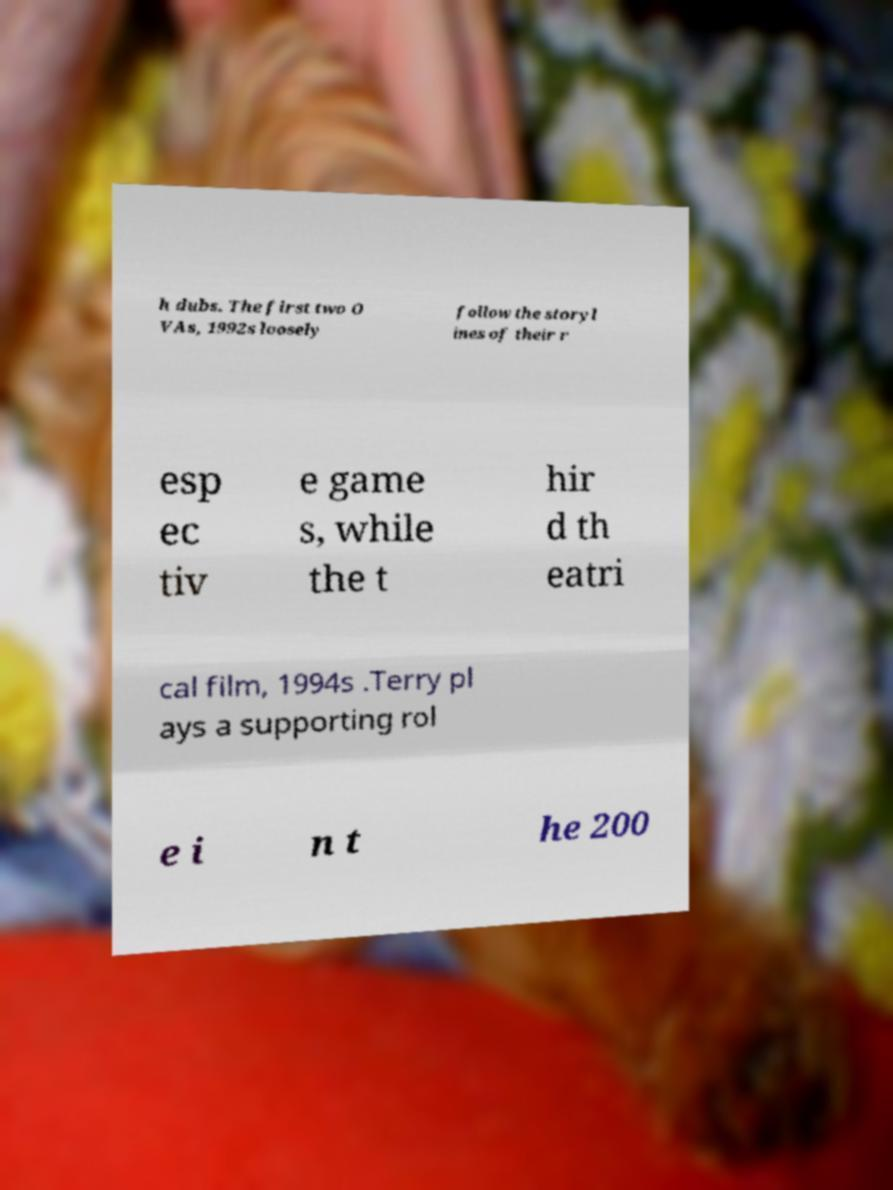What messages or text are displayed in this image? I need them in a readable, typed format. h dubs. The first two O VAs, 1992s loosely follow the storyl ines of their r esp ec tiv e game s, while the t hir d th eatri cal film, 1994s .Terry pl ays a supporting rol e i n t he 200 